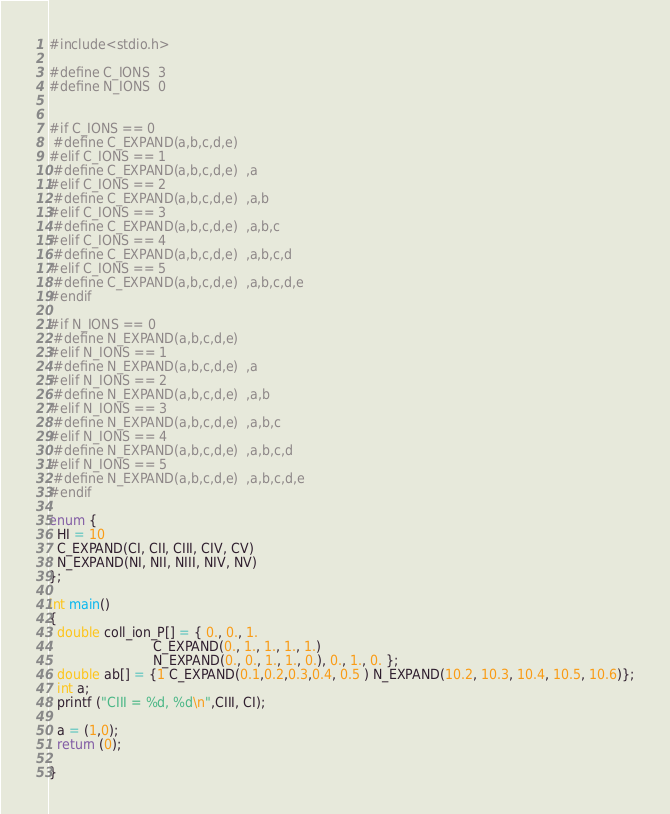Convert code to text. <code><loc_0><loc_0><loc_500><loc_500><_C_>#include<stdio.h>

#define C_IONS  3
#define N_IONS  0


#if C_IONS == 0
 #define C_EXPAND(a,b,c,d,e)  
#elif C_IONS == 1       
 #define C_EXPAND(a,b,c,d,e)  ,a
#elif C_IONS == 2     
 #define C_EXPAND(a,b,c,d,e)  ,a,b
#elif C_IONS == 3       
 #define C_EXPAND(a,b,c,d,e)  ,a,b,c
#elif C_IONS == 4
 #define C_EXPAND(a,b,c,d,e)  ,a,b,c,d
#elif C_IONS == 5      
 #define C_EXPAND(a,b,c,d,e)  ,a,b,c,d,e
#endif

#if N_IONS == 0
 #define N_EXPAND(a,b,c,d,e)  
#elif N_IONS == 1      
 #define N_EXPAND(a,b,c,d,e)  ,a
#elif N_IONS == 2     
 #define N_EXPAND(a,b,c,d,e)  ,a,b
#elif N_IONS == 3       
 #define N_EXPAND(a,b,c,d,e)  ,a,b,c
#elif N_IONS == 4
 #define N_EXPAND(a,b,c,d,e)  ,a,b,c,d
#elif N_IONS == 5      
 #define N_EXPAND(a,b,c,d,e)  ,a,b,c,d,e
#endif

enum {
  HI = 10
  C_EXPAND(CI, CII, CIII, CIV, CV)
  N_EXPAND(NI, NII, NIII, NIV, NV)
};

int main()
{
  double coll_ion_P[] = { 0., 0., 1.
                          C_EXPAND(0., 1., 1., 1., 1.)
                          N_EXPAND(0., 0., 1., 1., 0.), 0., 1., 0. }; 
  double ab[] = {1 C_EXPAND(0.1,0.2,0.3,0.4, 0.5 ) N_EXPAND(10.2, 10.3, 10.4, 10.5, 10.6)};
  int a;
  printf ("CIII = %d, %d\n",CIII, CI);

  a = (1,0);
  return (0);

}


</code> 